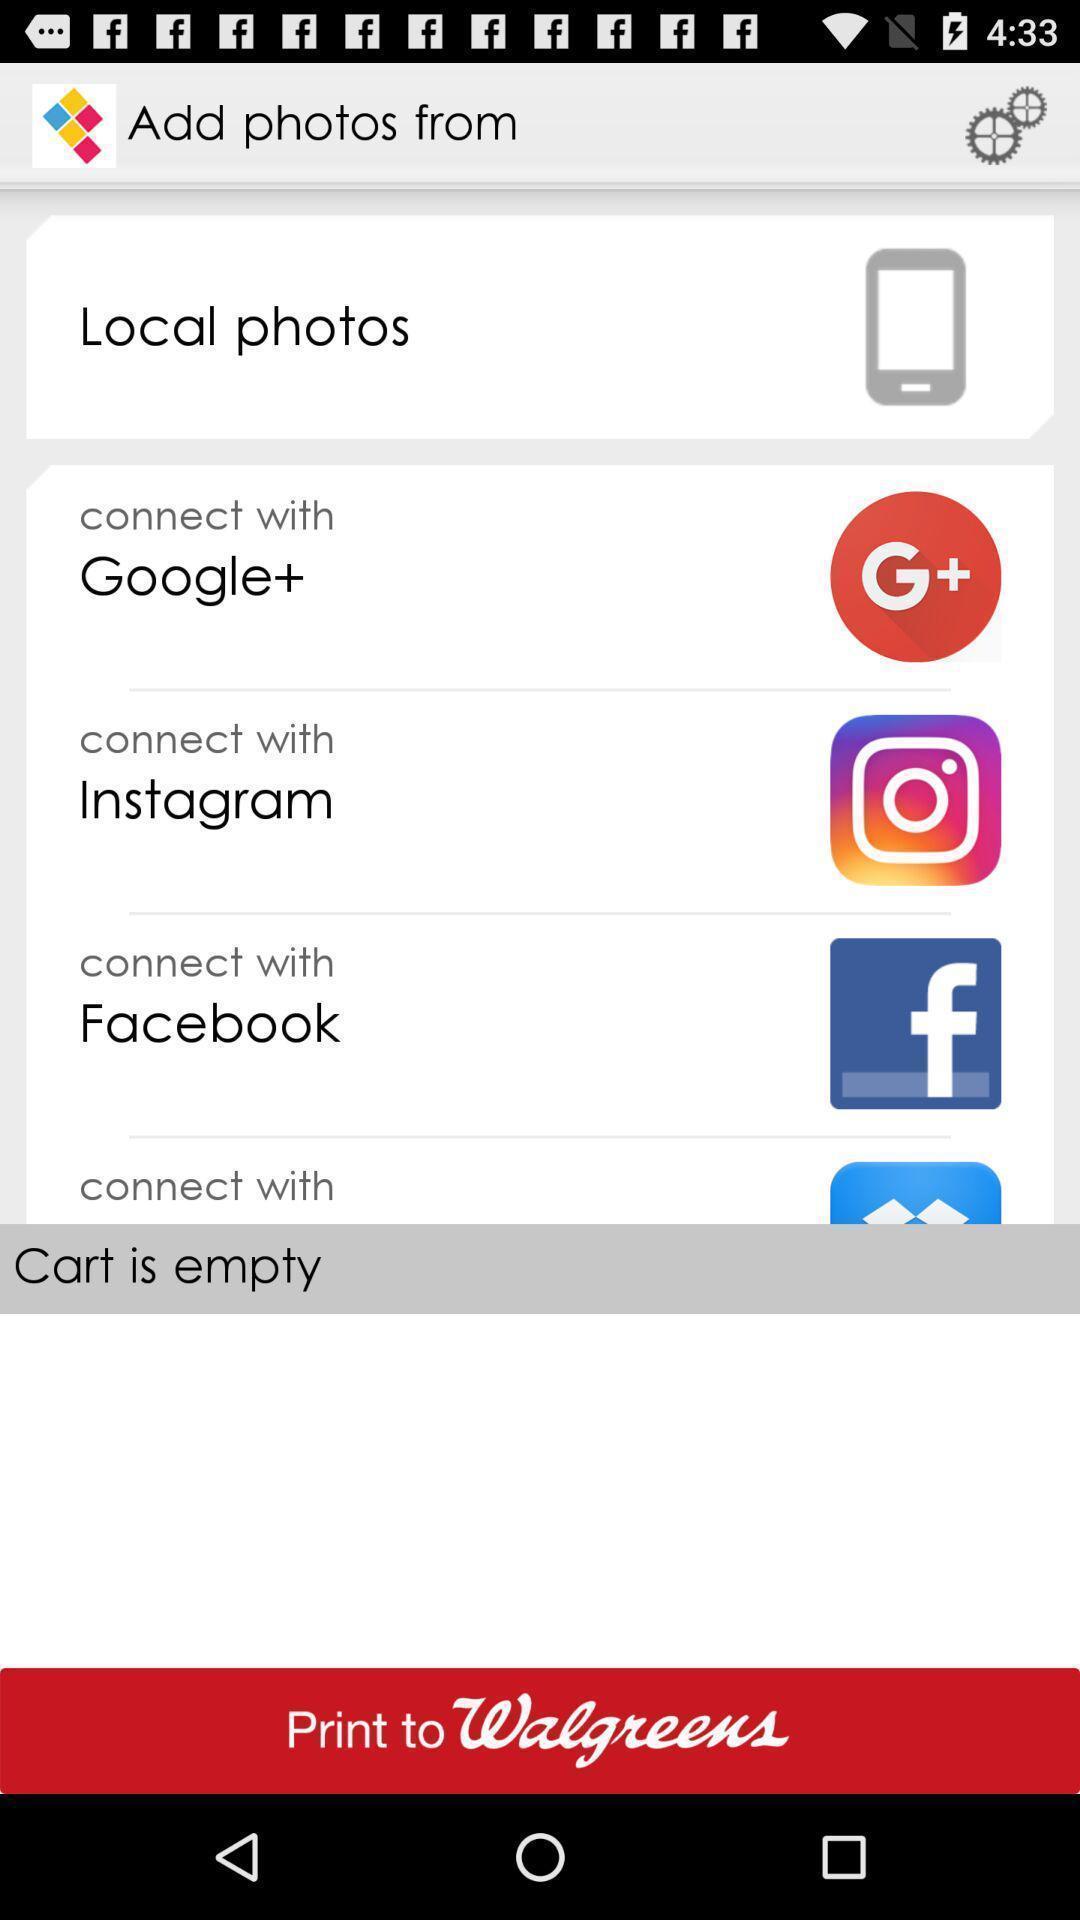Please provide a description for this image. Page displaying various social accounts to connect. 